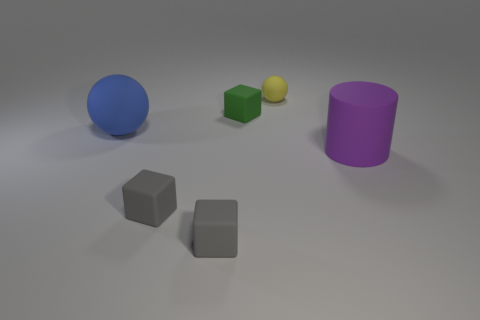Are any big green matte cubes visible?
Keep it short and to the point. No. There is a ball right of the big rubber object that is to the left of the purple rubber cylinder; how big is it?
Give a very brief answer. Small. Are there more tiny matte objects that are on the right side of the green cube than purple objects behind the small yellow matte thing?
Your response must be concise. Yes. What number of blocks are tiny gray shiny things or tiny objects?
Provide a short and direct response. 3. Are there any other things that have the same size as the purple cylinder?
Provide a short and direct response. Yes. Is the shape of the big matte object that is to the left of the yellow thing the same as  the tiny yellow matte thing?
Your answer should be very brief. Yes. The large matte cylinder is what color?
Offer a terse response. Purple. There is another object that is the same shape as the blue object; what is its color?
Provide a short and direct response. Yellow. What number of other big matte objects have the same shape as the green object?
Your answer should be very brief. 0. How many objects are either big gray metal objects or small matte things behind the blue object?
Provide a succinct answer. 2. 